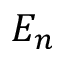<formula> <loc_0><loc_0><loc_500><loc_500>E _ { n }</formula> 